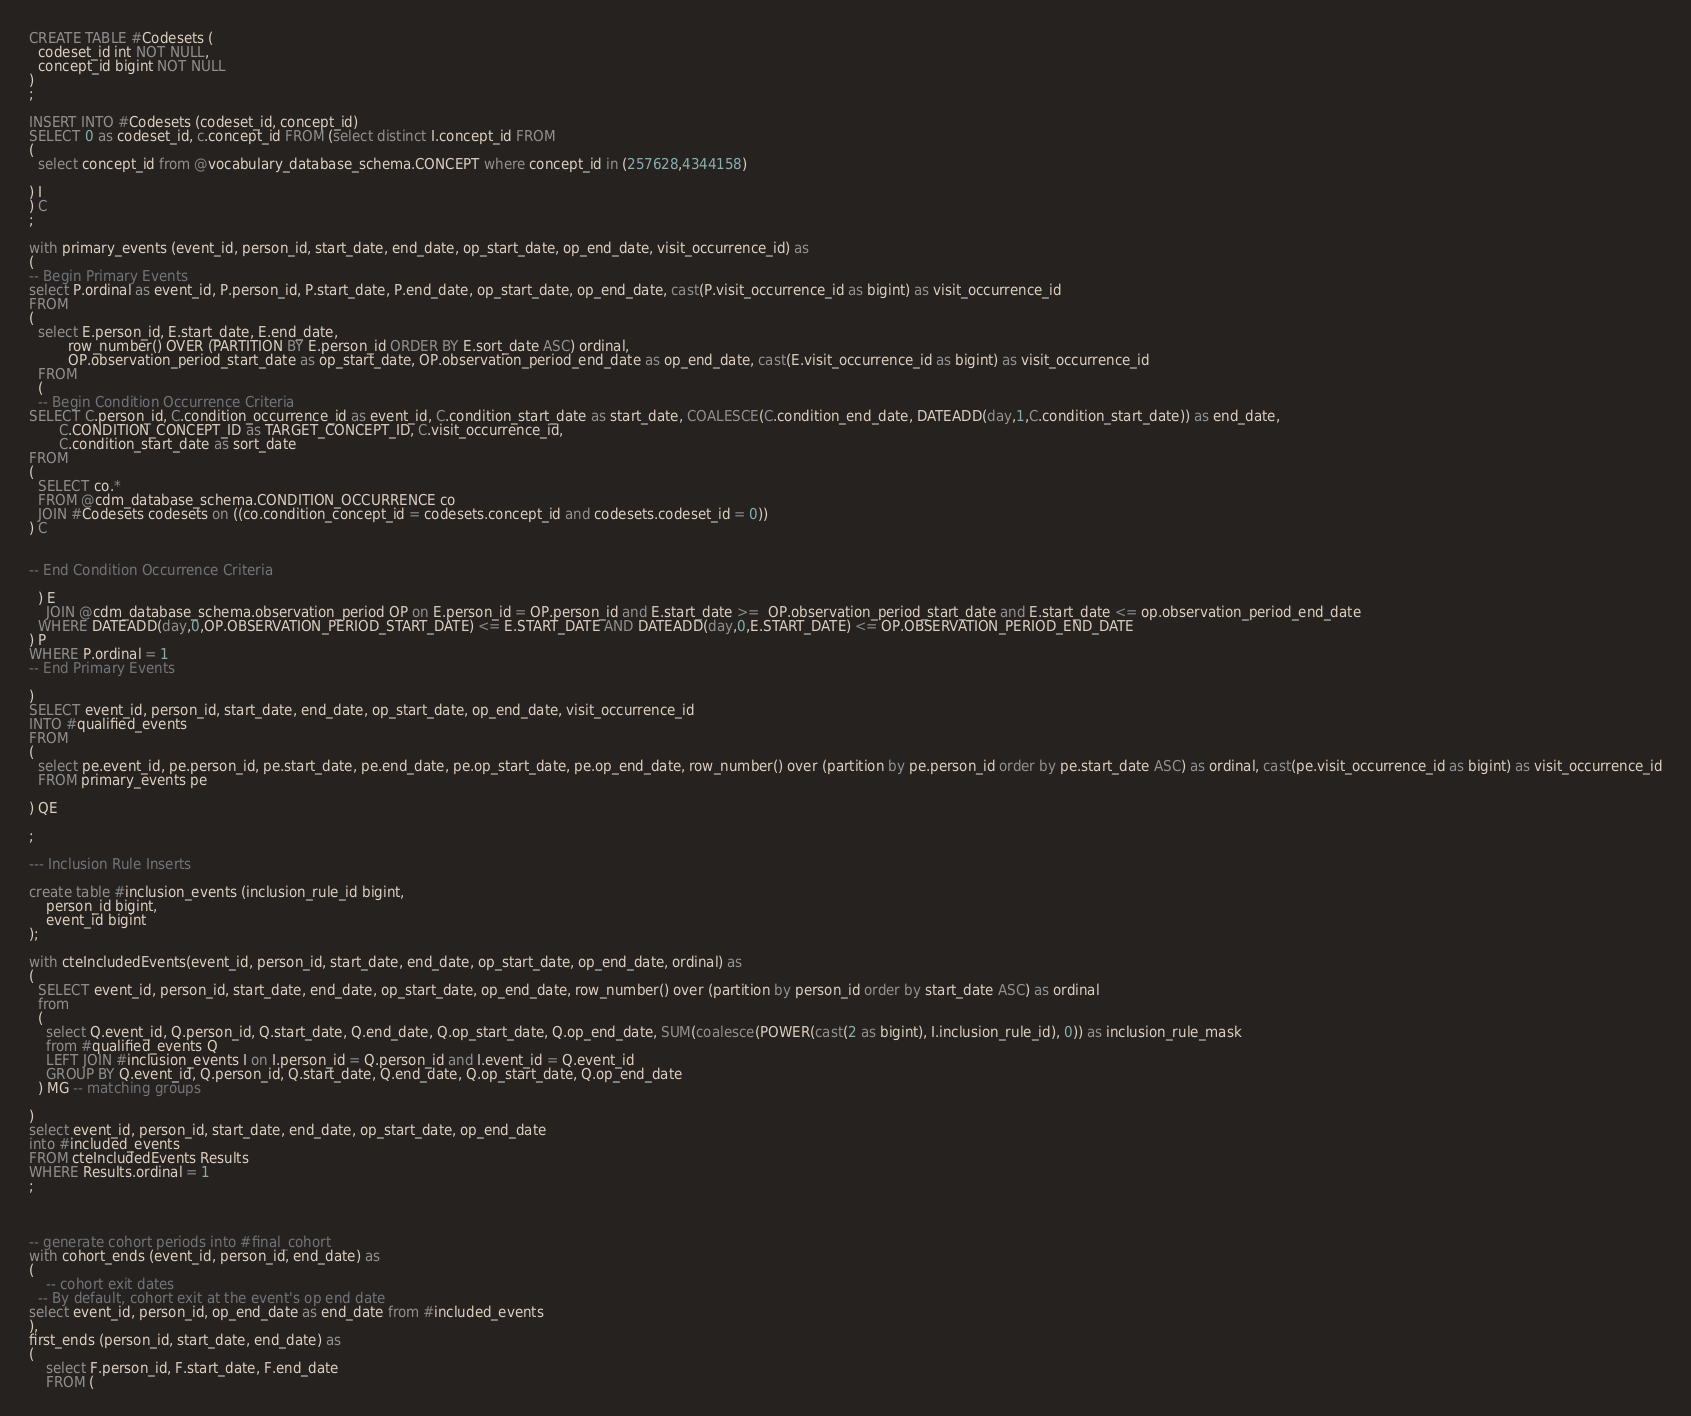<code> <loc_0><loc_0><loc_500><loc_500><_SQL_>CREATE TABLE #Codesets (
  codeset_id int NOT NULL,
  concept_id bigint NOT NULL
)
;

INSERT INTO #Codesets (codeset_id, concept_id)
SELECT 0 as codeset_id, c.concept_id FROM (select distinct I.concept_id FROM
( 
  select concept_id from @vocabulary_database_schema.CONCEPT where concept_id in (257628,4344158)

) I
) C
;

with primary_events (event_id, person_id, start_date, end_date, op_start_date, op_end_date, visit_occurrence_id) as
(
-- Begin Primary Events
select P.ordinal as event_id, P.person_id, P.start_date, P.end_date, op_start_date, op_end_date, cast(P.visit_occurrence_id as bigint) as visit_occurrence_id
FROM
(
  select E.person_id, E.start_date, E.end_date,
         row_number() OVER (PARTITION BY E.person_id ORDER BY E.sort_date ASC) ordinal,
         OP.observation_period_start_date as op_start_date, OP.observation_period_end_date as op_end_date, cast(E.visit_occurrence_id as bigint) as visit_occurrence_id
  FROM 
  (
  -- Begin Condition Occurrence Criteria
SELECT C.person_id, C.condition_occurrence_id as event_id, C.condition_start_date as start_date, COALESCE(C.condition_end_date, DATEADD(day,1,C.condition_start_date)) as end_date,
       C.CONDITION_CONCEPT_ID as TARGET_CONCEPT_ID, C.visit_occurrence_id,
       C.condition_start_date as sort_date
FROM 
(
  SELECT co.* 
  FROM @cdm_database_schema.CONDITION_OCCURRENCE co
  JOIN #Codesets codesets on ((co.condition_concept_id = codesets.concept_id and codesets.codeset_id = 0))
) C


-- End Condition Occurrence Criteria

  ) E
	JOIN @cdm_database_schema.observation_period OP on E.person_id = OP.person_id and E.start_date >=  OP.observation_period_start_date and E.start_date <= op.observation_period_end_date
  WHERE DATEADD(day,0,OP.OBSERVATION_PERIOD_START_DATE) <= E.START_DATE AND DATEADD(day,0,E.START_DATE) <= OP.OBSERVATION_PERIOD_END_DATE
) P
WHERE P.ordinal = 1
-- End Primary Events

)
SELECT event_id, person_id, start_date, end_date, op_start_date, op_end_date, visit_occurrence_id
INTO #qualified_events
FROM 
(
  select pe.event_id, pe.person_id, pe.start_date, pe.end_date, pe.op_start_date, pe.op_end_date, row_number() over (partition by pe.person_id order by pe.start_date ASC) as ordinal, cast(pe.visit_occurrence_id as bigint) as visit_occurrence_id
  FROM primary_events pe
  
) QE

;

--- Inclusion Rule Inserts

create table #inclusion_events (inclusion_rule_id bigint,
	person_id bigint,
	event_id bigint
);

with cteIncludedEvents(event_id, person_id, start_date, end_date, op_start_date, op_end_date, ordinal) as
(
  SELECT event_id, person_id, start_date, end_date, op_start_date, op_end_date, row_number() over (partition by person_id order by start_date ASC) as ordinal
  from
  (
    select Q.event_id, Q.person_id, Q.start_date, Q.end_date, Q.op_start_date, Q.op_end_date, SUM(coalesce(POWER(cast(2 as bigint), I.inclusion_rule_id), 0)) as inclusion_rule_mask
    from #qualified_events Q
    LEFT JOIN #inclusion_events I on I.person_id = Q.person_id and I.event_id = Q.event_id
    GROUP BY Q.event_id, Q.person_id, Q.start_date, Q.end_date, Q.op_start_date, Q.op_end_date
  ) MG -- matching groups

)
select event_id, person_id, start_date, end_date, op_start_date, op_end_date
into #included_events
FROM cteIncludedEvents Results
WHERE Results.ordinal = 1
;



-- generate cohort periods into #final_cohort
with cohort_ends (event_id, person_id, end_date) as
(
	-- cohort exit dates
  -- By default, cohort exit at the event's op end date
select event_id, person_id, op_end_date as end_date from #included_events
),
first_ends (person_id, start_date, end_date) as
(
	select F.person_id, F.start_date, F.end_date
	FROM (</code> 